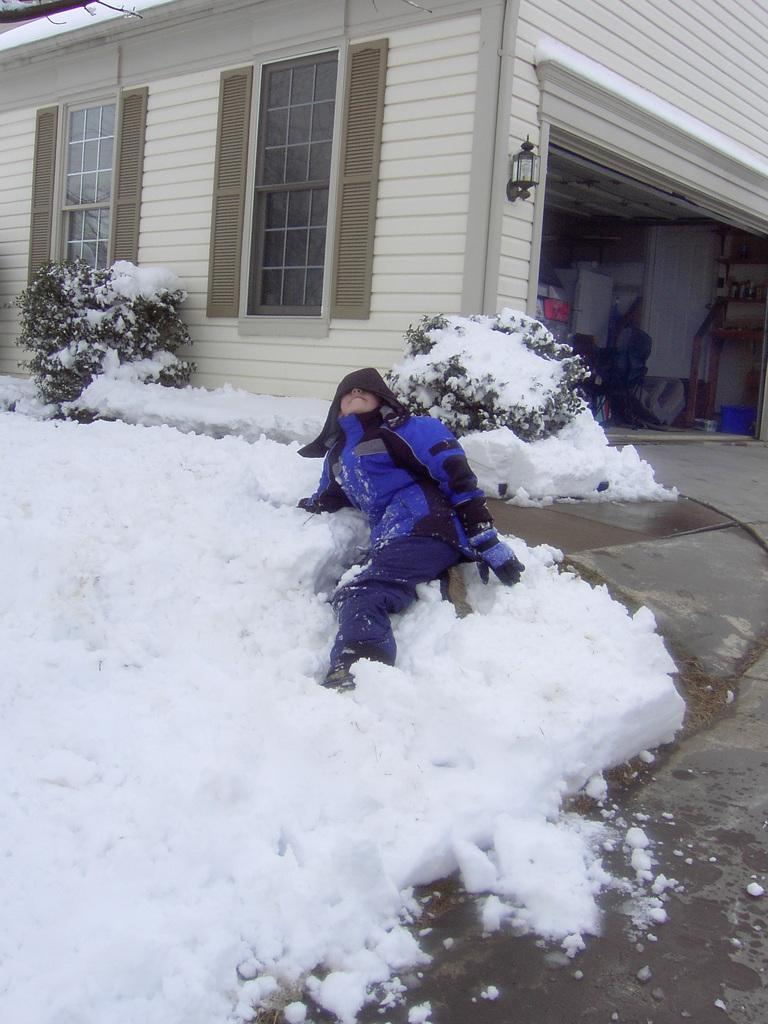Who or what is present in the image? There is a person in the image. What is the condition of the plants in the image? The plants are covered with snow in the image. What structure can be seen in the image? There is a shed in the image. What is inside the shed? There is a vehicle inside the shed, along with other objects. Where is the baseball located in the image? There is no baseball present in the image. What is the limit of the hydrant's reach in the image? There is no hydrant present in the image, so it is not possible to determine its reach. 